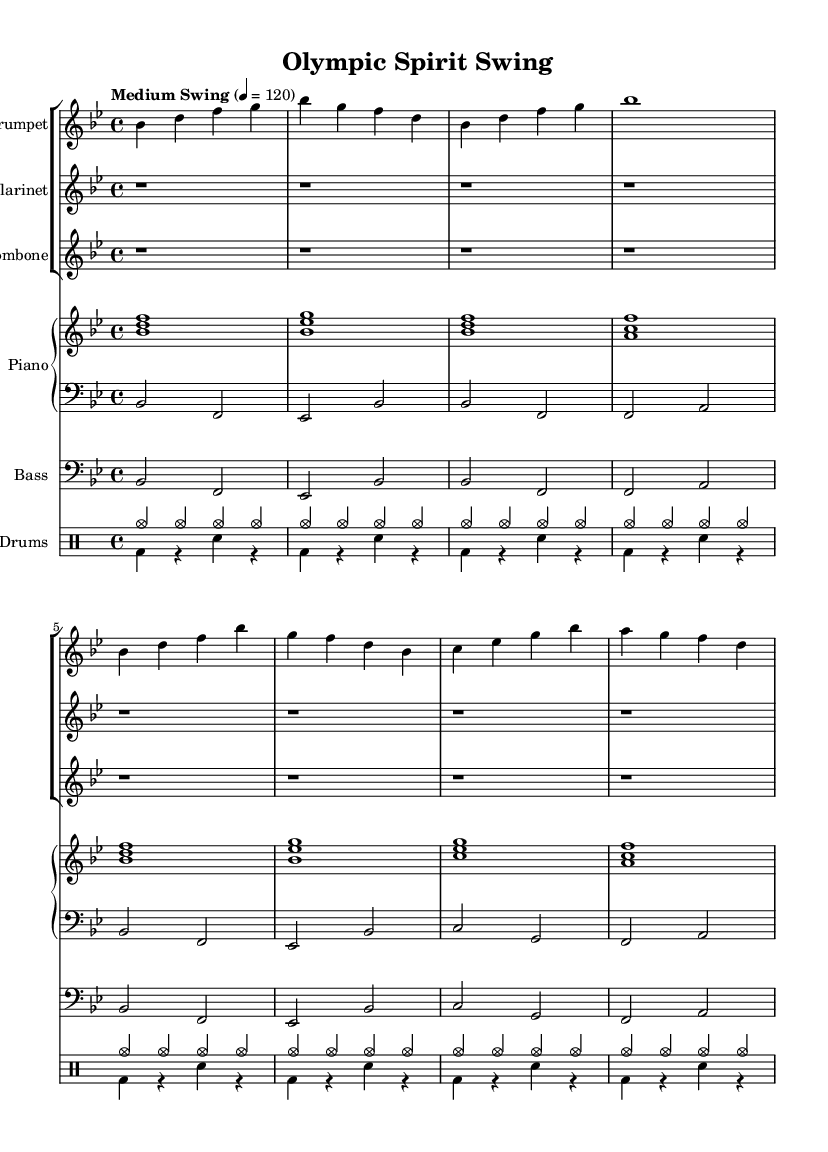What is the key signature of this music? The key signature is indicated by the symbols at the beginning of the staff. In this case, there is a flat on the second line, indicating that the key signature is B flat major, which has two flats.
Answer: B flat major What is the time signature of this music? The time signature is found at the beginning of the music, represented as a fraction. Here, it shows 4 over 4, which indicates that each measure has four beats, and the quarter note gets one beat.
Answer: 4/4 What is the tempo marking of this music? The tempo is indicated right above the staff with the words "Medium Swing" followed by a metronome marking of 120. This indicates the speed at which the piece should be played.
Answer: Medium Swing How many instruments are featured in the score? To determine the number of instruments, we can count the distinct staves listed in the score section. There are six staves for different instruments: Trumpet, Clarinet, Trombone, two for Piano, Bass, and Drums, totaling seven instruments.
Answer: Seven Which section starts with a rest? By checking the notation at the beginning of the clarinet and trombone staves, we see that both start with a long rest symbol, indicating silence in their parts before they begin playing.
Answer: Clarinet What jazz style is represented in the piece? The title of the piece, "Olympic Spirit Swing," denotes that this composition reflects the New Orleans-style jazz, particularly celebrating vibrant sports destinations.
Answer: New Orleans-style jazz What type of musical section is labeled "A Section"? The terms used in the structure of the score often refer to the sections of the music, and "A Section" typically signifies the main theme or the primary theme being introduced in jazz, indicating the portion where the melody is highlighted.
Answer: Main theme 